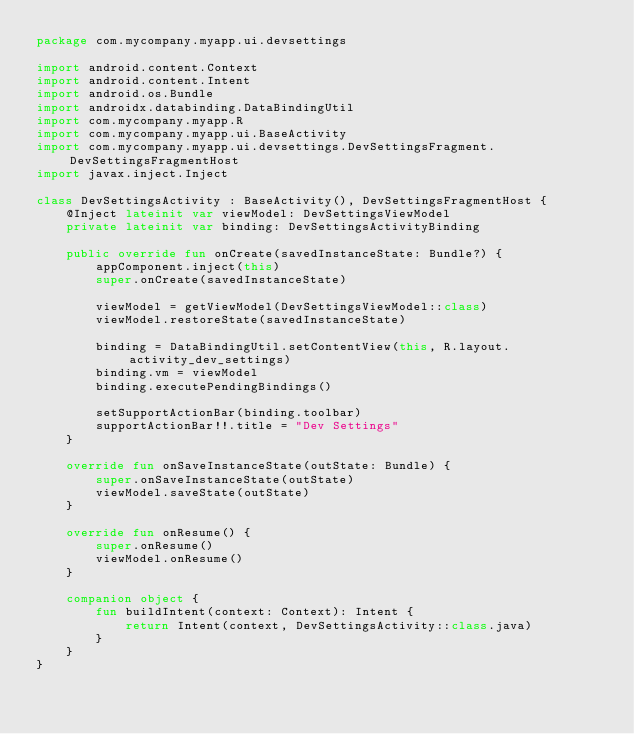Convert code to text. <code><loc_0><loc_0><loc_500><loc_500><_Kotlin_>package com.mycompany.myapp.ui.devsettings

import android.content.Context
import android.content.Intent
import android.os.Bundle
import androidx.databinding.DataBindingUtil
import com.mycompany.myapp.R
import com.mycompany.myapp.ui.BaseActivity
import com.mycompany.myapp.ui.devsettings.DevSettingsFragment.DevSettingsFragmentHost
import javax.inject.Inject

class DevSettingsActivity : BaseActivity(), DevSettingsFragmentHost {
    @Inject lateinit var viewModel: DevSettingsViewModel
    private lateinit var binding: DevSettingsActivityBinding

    public override fun onCreate(savedInstanceState: Bundle?) {
        appComponent.inject(this)
        super.onCreate(savedInstanceState)

        viewModel = getViewModel(DevSettingsViewModel::class)
        viewModel.restoreState(savedInstanceState)

        binding = DataBindingUtil.setContentView(this, R.layout.activity_dev_settings)
        binding.vm = viewModel
        binding.executePendingBindings()

        setSupportActionBar(binding.toolbar)
        supportActionBar!!.title = "Dev Settings"
    }

    override fun onSaveInstanceState(outState: Bundle) {
        super.onSaveInstanceState(outState)
        viewModel.saveState(outState)
    }

    override fun onResume() {
        super.onResume()
        viewModel.onResume()
    }

    companion object {
        fun buildIntent(context: Context): Intent {
            return Intent(context, DevSettingsActivity::class.java)
        }
    }
}
</code> 